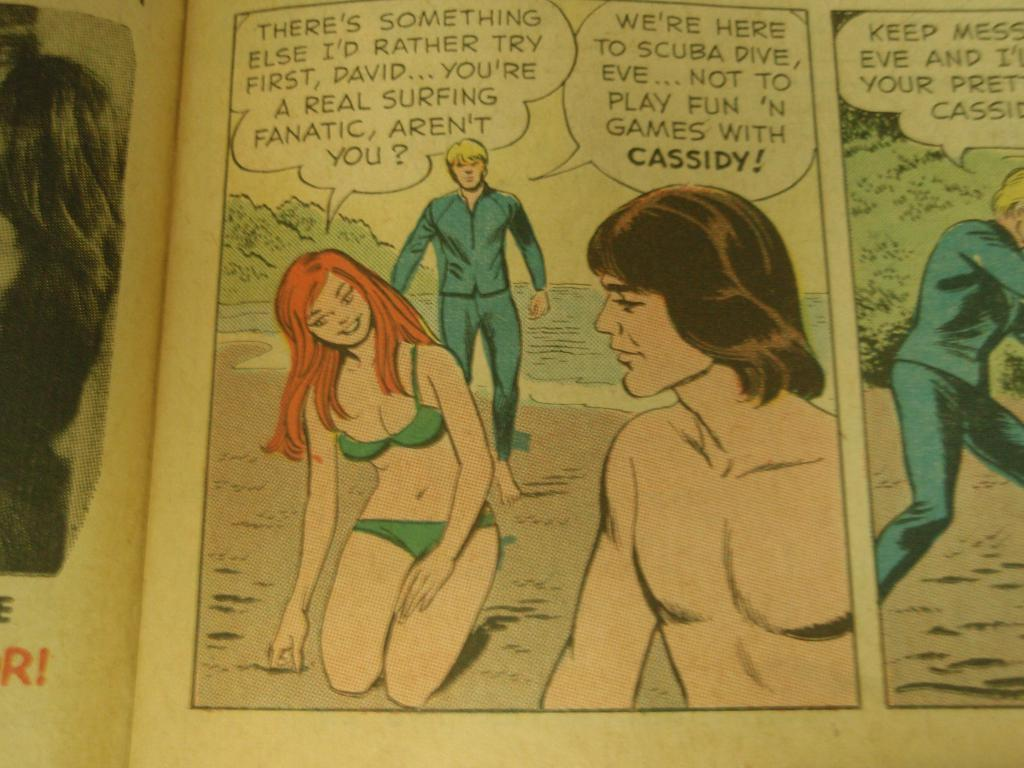<image>
Give a short and clear explanation of the subsequent image. A comic that reads they are there to scuba dive not play fun games with Cassidy. 